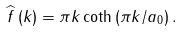<formula> <loc_0><loc_0><loc_500><loc_500>\widehat { f } \left ( k \right ) = \pi k \coth \left ( \pi k / a _ { 0 } \right ) .</formula> 